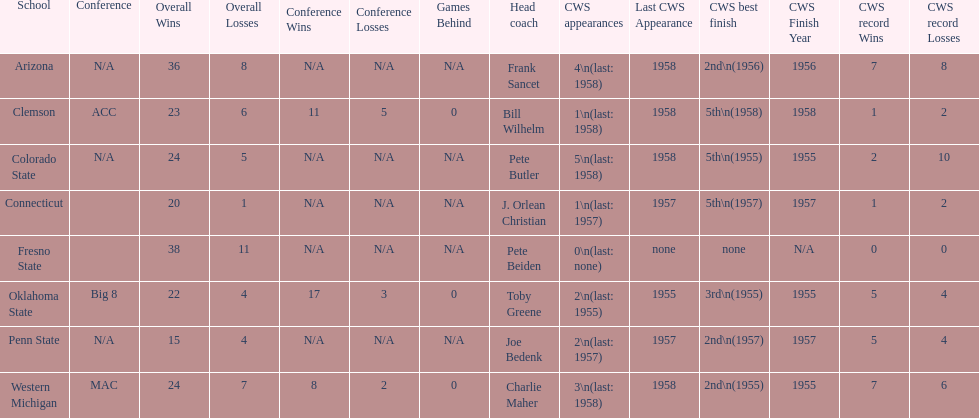List each of the schools that came in 2nd for cws best finish. Arizona, Penn State, Western Michigan. 